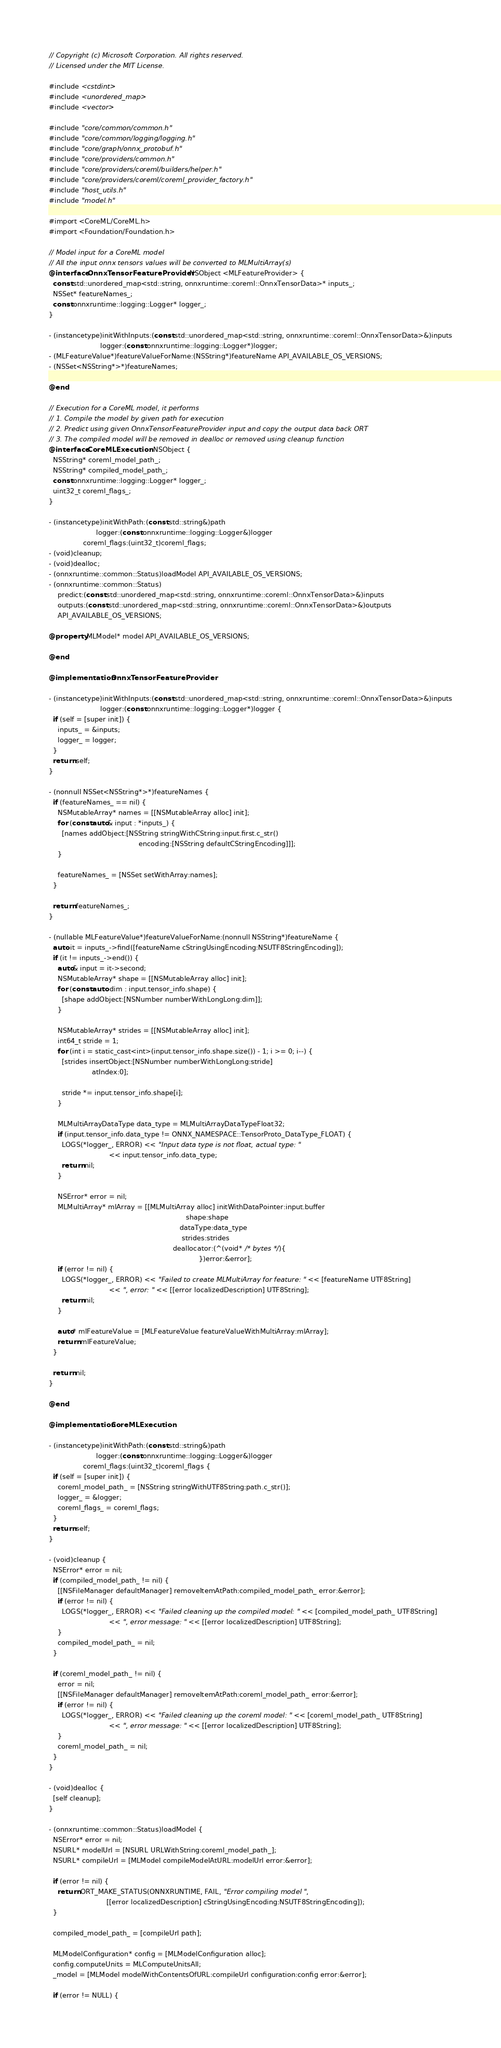Convert code to text. <code><loc_0><loc_0><loc_500><loc_500><_ObjectiveC_>// Copyright (c) Microsoft Corporation. All rights reserved.
// Licensed under the MIT License.

#include <cstdint>
#include <unordered_map>
#include <vector>

#include "core/common/common.h"
#include "core/common/logging/logging.h"
#include "core/graph/onnx_protobuf.h"
#include "core/providers/common.h"
#include "core/providers/coreml/builders/helper.h"
#include "core/providers/coreml/coreml_provider_factory.h"
#include "host_utils.h"
#include "model.h"

#import <CoreML/CoreML.h>
#import <Foundation/Foundation.h>

// Model input for a CoreML model
// All the input onnx tensors values will be converted to MLMultiArray(s)
@interface OnnxTensorFeatureProvider : NSObject <MLFeatureProvider> {
  const std::unordered_map<std::string, onnxruntime::coreml::OnnxTensorData>* inputs_;
  NSSet* featureNames_;
  const onnxruntime::logging::Logger* logger_;
}

- (instancetype)initWithInputs:(const std::unordered_map<std::string, onnxruntime::coreml::OnnxTensorData>&)inputs
                        logger:(const onnxruntime::logging::Logger*)logger;
- (MLFeatureValue*)featureValueForName:(NSString*)featureName API_AVAILABLE_OS_VERSIONS;
- (NSSet<NSString*>*)featureNames;

@end

// Execution for a CoreML model, it performs
// 1. Compile the model by given path for execution
// 2. Predict using given OnnxTensorFeatureProvider input and copy the output data back ORT
// 3. The compiled model will be removed in dealloc or removed using cleanup function
@interface CoreMLExecution : NSObject {
  NSString* coreml_model_path_;
  NSString* compiled_model_path_;
  const onnxruntime::logging::Logger* logger_;
  uint32_t coreml_flags_;
}

- (instancetype)initWithPath:(const std::string&)path
                      logger:(const onnxruntime::logging::Logger&)logger
                coreml_flags:(uint32_t)coreml_flags;
- (void)cleanup;
- (void)dealloc;
- (onnxruntime::common::Status)loadModel API_AVAILABLE_OS_VERSIONS;
- (onnxruntime::common::Status)
    predict:(const std::unordered_map<std::string, onnxruntime::coreml::OnnxTensorData>&)inputs
    outputs:(const std::unordered_map<std::string, onnxruntime::coreml::OnnxTensorData>&)outputs
    API_AVAILABLE_OS_VERSIONS;

@property MLModel* model API_AVAILABLE_OS_VERSIONS;

@end

@implementation OnnxTensorFeatureProvider

- (instancetype)initWithInputs:(const std::unordered_map<std::string, onnxruntime::coreml::OnnxTensorData>&)inputs
                        logger:(const onnxruntime::logging::Logger*)logger {
  if (self = [super init]) {
    inputs_ = &inputs;
    logger_ = logger;
  }
  return self;
}

- (nonnull NSSet<NSString*>*)featureNames {
  if (featureNames_ == nil) {
    NSMutableArray* names = [[NSMutableArray alloc] init];
    for (const auto& input : *inputs_) {
      [names addObject:[NSString stringWithCString:input.first.c_str()
                                          encoding:[NSString defaultCStringEncoding]]];
    }

    featureNames_ = [NSSet setWithArray:names];
  }

  return featureNames_;
}

- (nullable MLFeatureValue*)featureValueForName:(nonnull NSString*)featureName {
  auto it = inputs_->find([featureName cStringUsingEncoding:NSUTF8StringEncoding]);
  if (it != inputs_->end()) {
    auto& input = it->second;
    NSMutableArray* shape = [[NSMutableArray alloc] init];
    for (const auto dim : input.tensor_info.shape) {
      [shape addObject:[NSNumber numberWithLongLong:dim]];
    }

    NSMutableArray* strides = [[NSMutableArray alloc] init];
    int64_t stride = 1;
    for (int i = static_cast<int>(input.tensor_info.shape.size()) - 1; i >= 0; i--) {
      [strides insertObject:[NSNumber numberWithLongLong:stride]
                    atIndex:0];

      stride *= input.tensor_info.shape[i];
    }

    MLMultiArrayDataType data_type = MLMultiArrayDataTypeFloat32;
    if (input.tensor_info.data_type != ONNX_NAMESPACE::TensorProto_DataType_FLOAT) {
      LOGS(*logger_, ERROR) << "Input data type is not float, actual type: "
                            << input.tensor_info.data_type;
      return nil;
    }

    NSError* error = nil;
    MLMultiArray* mlArray = [[MLMultiArray alloc] initWithDataPointer:input.buffer
                                                                shape:shape
                                                             dataType:data_type
                                                              strides:strides
                                                          deallocator:(^(void* /* bytes */){
                                                                      })error:&error];
    if (error != nil) {
      LOGS(*logger_, ERROR) << "Failed to create MLMultiArray for feature: " << [featureName UTF8String]
                            << ", error: " << [[error localizedDescription] UTF8String];
      return nil;
    }

    auto* mlFeatureValue = [MLFeatureValue featureValueWithMultiArray:mlArray];
    return mlFeatureValue;
  }

  return nil;
}

@end

@implementation CoreMLExecution

- (instancetype)initWithPath:(const std::string&)path
                      logger:(const onnxruntime::logging::Logger&)logger
                coreml_flags:(uint32_t)coreml_flags {
  if (self = [super init]) {
    coreml_model_path_ = [NSString stringWithUTF8String:path.c_str()];
    logger_ = &logger;
    coreml_flags_ = coreml_flags;
  }
  return self;
}

- (void)cleanup {
  NSError* error = nil;
  if (compiled_model_path_ != nil) {
    [[NSFileManager defaultManager] removeItemAtPath:compiled_model_path_ error:&error];
    if (error != nil) {
      LOGS(*logger_, ERROR) << "Failed cleaning up the compiled model: " << [compiled_model_path_ UTF8String]
                            << ", error message: " << [[error localizedDescription] UTF8String];
    }
    compiled_model_path_ = nil;
  }

  if (coreml_model_path_ != nil) {
    error = nil;
    [[NSFileManager defaultManager] removeItemAtPath:coreml_model_path_ error:&error];
    if (error != nil) {
      LOGS(*logger_, ERROR) << "Failed cleaning up the coreml model: " << [coreml_model_path_ UTF8String]
                            << ", error message: " << [[error localizedDescription] UTF8String];
    }
    coreml_model_path_ = nil;
  }
}

- (void)dealloc {
  [self cleanup];
}

- (onnxruntime::common::Status)loadModel {
  NSError* error = nil;
  NSURL* modelUrl = [NSURL URLWithString:coreml_model_path_];
  NSURL* compileUrl = [MLModel compileModelAtURL:modelUrl error:&error];

  if (error != nil) {
    return ORT_MAKE_STATUS(ONNXRUNTIME, FAIL, "Error compiling model ",
                           [[error localizedDescription] cStringUsingEncoding:NSUTF8StringEncoding]);
  }

  compiled_model_path_ = [compileUrl path];

  MLModelConfiguration* config = [MLModelConfiguration alloc];
  config.computeUnits = MLComputeUnitsAll;
  _model = [MLModel modelWithContentsOfURL:compileUrl configuration:config error:&error];

  if (error != NULL) {</code> 